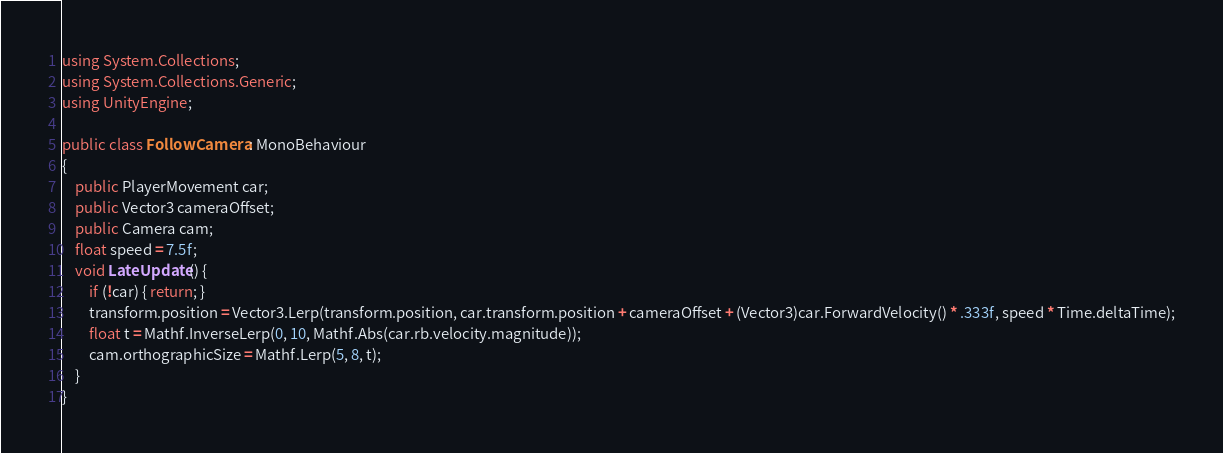<code> <loc_0><loc_0><loc_500><loc_500><_C#_>using System.Collections;
using System.Collections.Generic;
using UnityEngine;

public class FollowCamera : MonoBehaviour
{
    public PlayerMovement car;
    public Vector3 cameraOffset;
    public Camera cam;
    float speed = 7.5f;
    void LateUpdate() {
        if (!car) { return; }
        transform.position = Vector3.Lerp(transform.position, car.transform.position + cameraOffset + (Vector3)car.ForwardVelocity() * .333f, speed * Time.deltaTime);
        float t = Mathf.InverseLerp(0, 10, Mathf.Abs(car.rb.velocity.magnitude));
        cam.orthographicSize = Mathf.Lerp(5, 8, t);
    }
}
</code> 